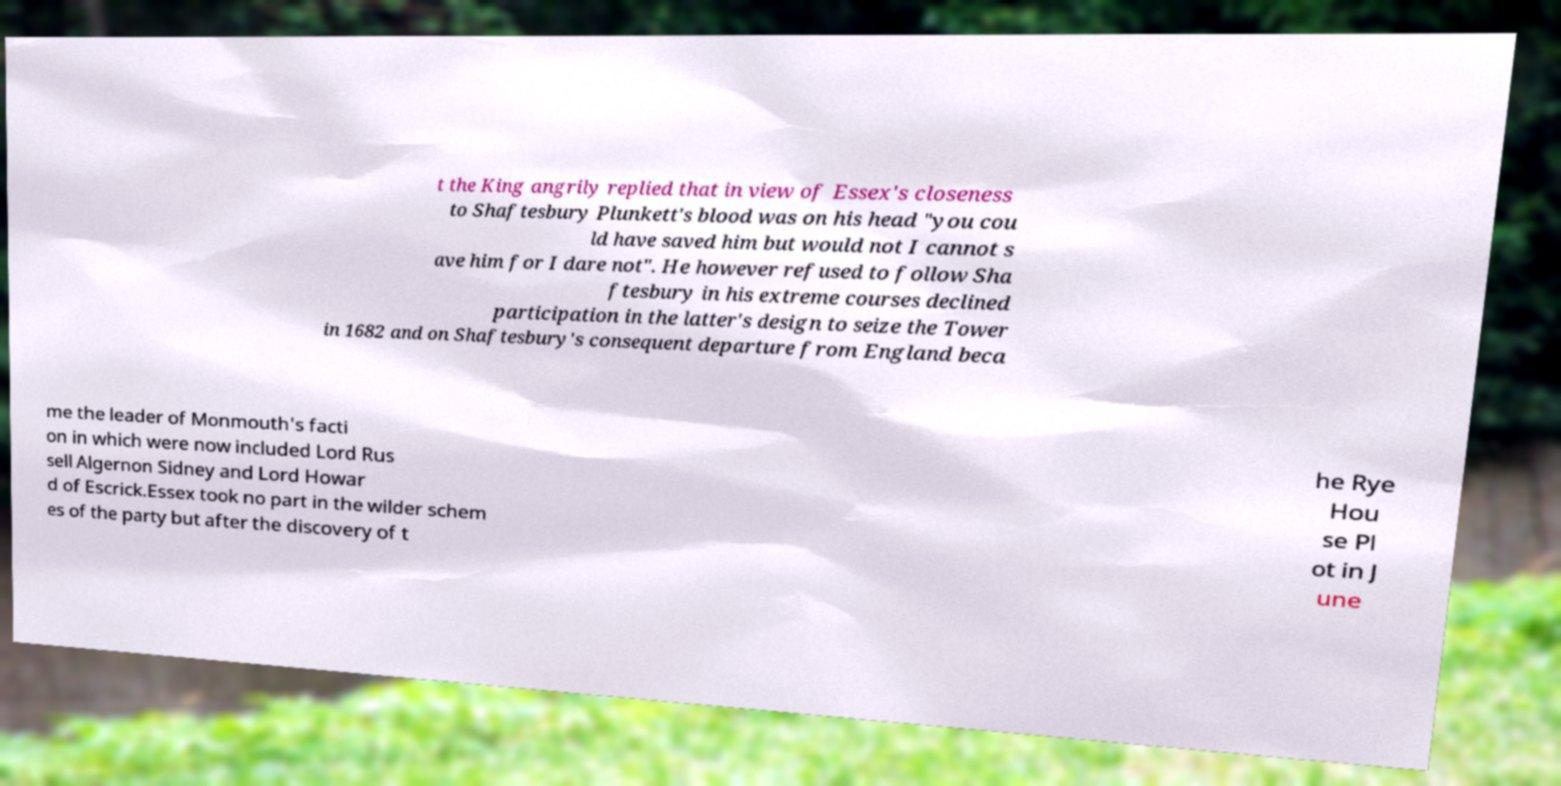Please identify and transcribe the text found in this image. t the King angrily replied that in view of Essex's closeness to Shaftesbury Plunkett's blood was on his head "you cou ld have saved him but would not I cannot s ave him for I dare not". He however refused to follow Sha ftesbury in his extreme courses declined participation in the latter's design to seize the Tower in 1682 and on Shaftesbury's consequent departure from England beca me the leader of Monmouth's facti on in which were now included Lord Rus sell Algernon Sidney and Lord Howar d of Escrick.Essex took no part in the wilder schem es of the party but after the discovery of t he Rye Hou se Pl ot in J une 